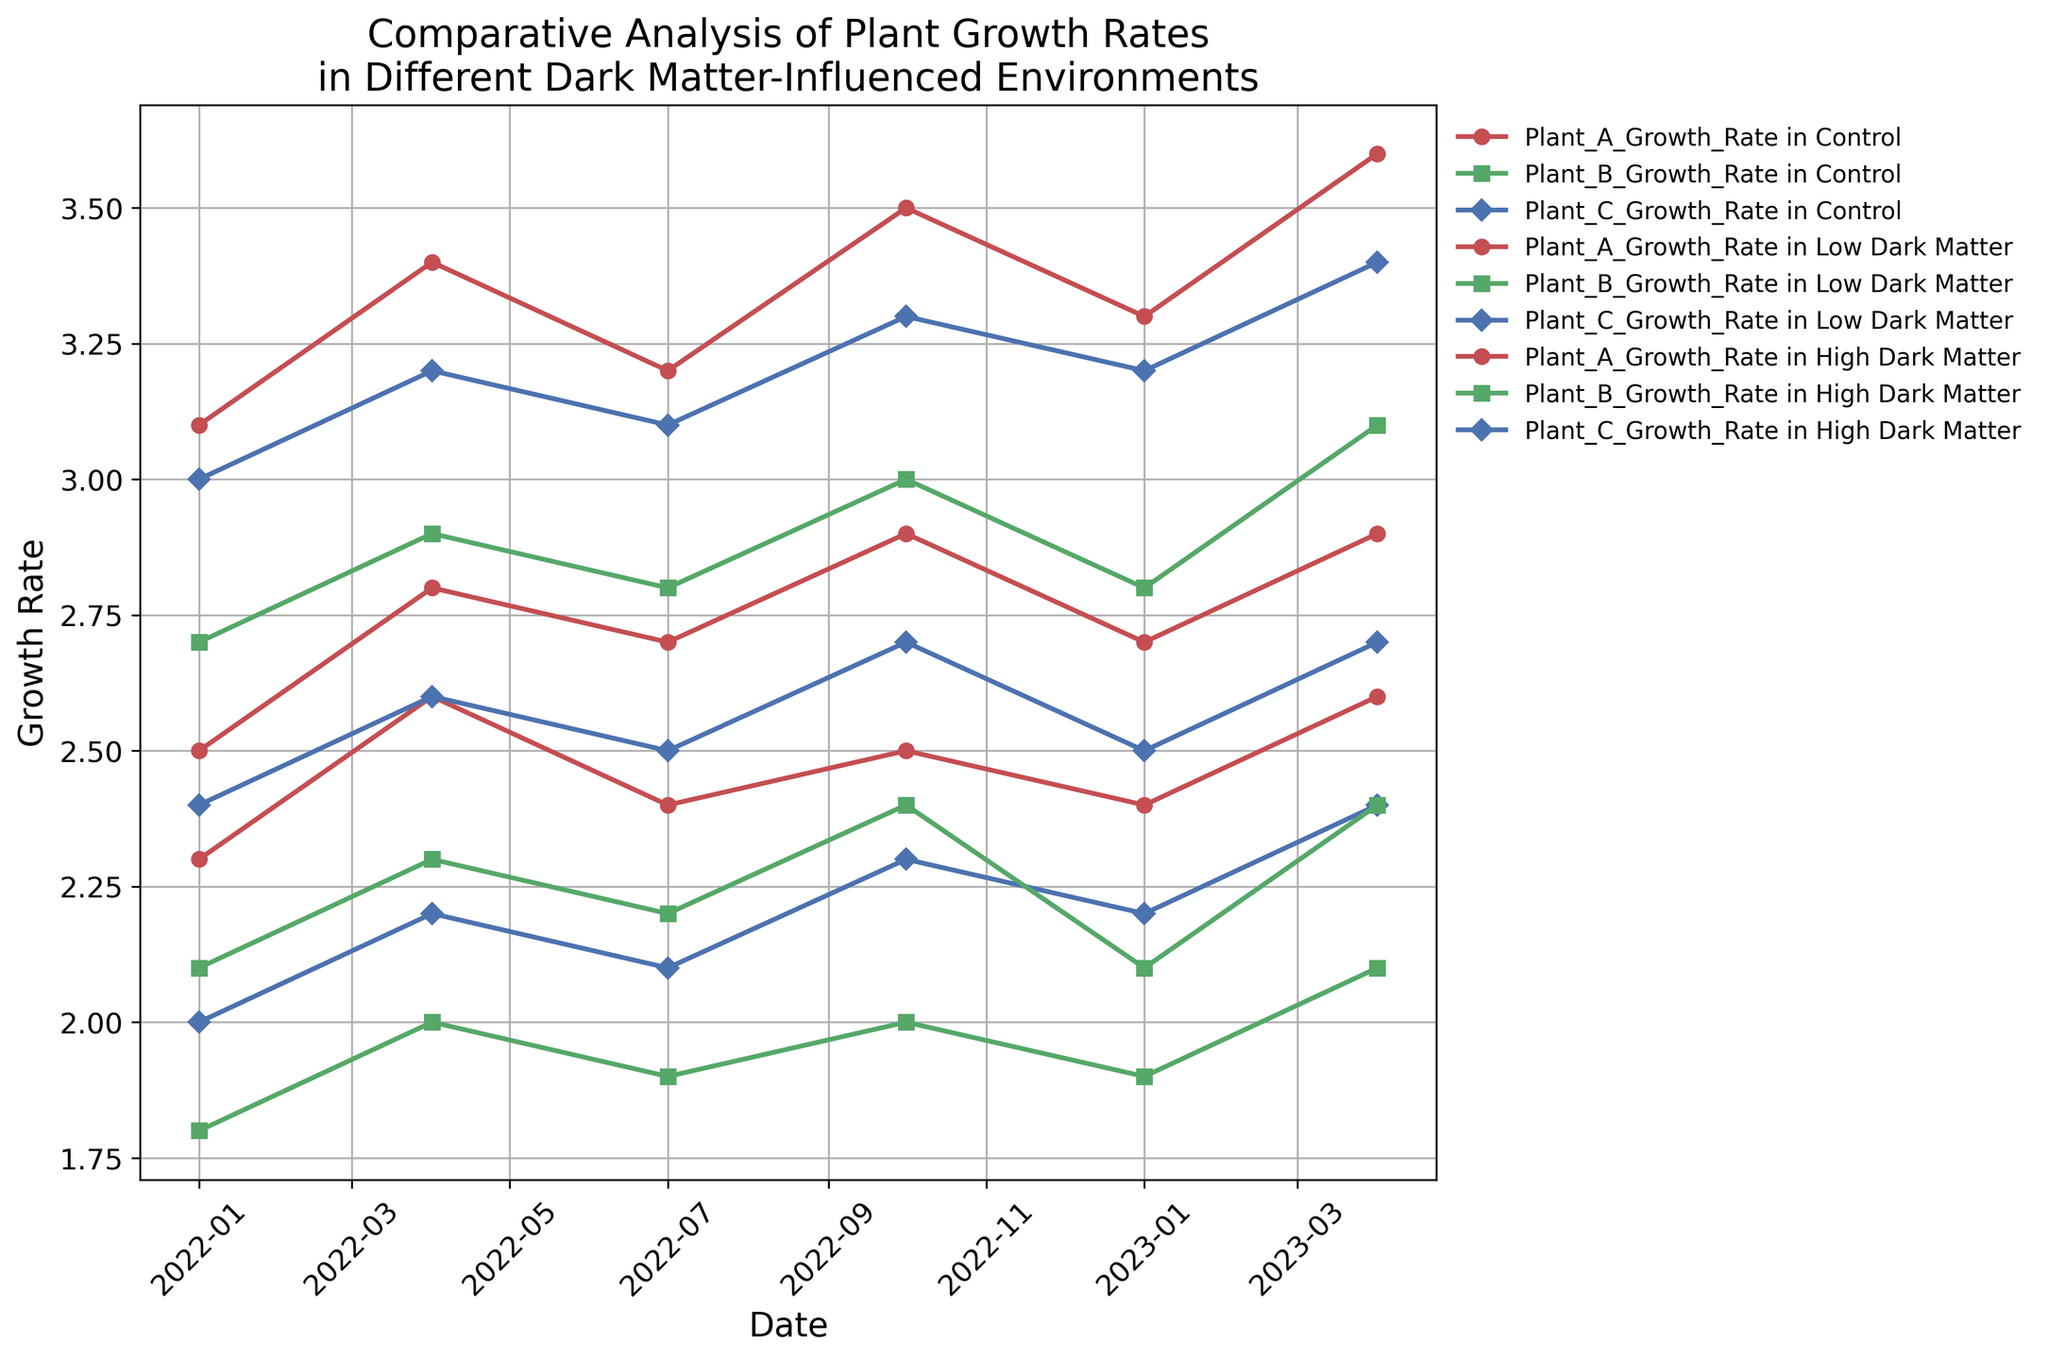What are the plant growth rates for Plant A in the High Dark Matter environment on 2022-04-01 and 2023-04-01? Look at the plot for the High Dark Matter environment and find the growth rate for Plant A on the dates 2022-04-01 and 2023-04-01. On 2022-04-01, it's 3.4, and on 2023-04-01, it's 3.6.
Answer: 3.4 and 3.6 Which environment shows the highest growth rate for Plant C in January 2023? Compare the growth rates of Plant C across all environments in January 2023. The highest growth rate for Plant C in January 2023 is in the High Dark Matter environment with a value of 3.2.
Answer: High Dark Matter Calculate the average growth rate of Plant B in the Low Dark Matter environment over the entire period. Sum the growth rates of Plant B in the Low Dark Matter environment for all given dates and divide by the number of dates. The rates are 2.1, 2.3, 2.2, 2.4, 2.1, 2.4. Sum them up (2.1 + 2.3 + 2.2 + 2.4 + 2.1 + 2.4) = 13.5, and then divide by 6. The average is 13.5/6 = 2.25.
Answer: 2.25 Which Plant shows a consistent increase in growth rate across all environments from January 2022 to April 2023? Check each plant's growth rates across all environments to see if there's a consistent increase from January 2022 to April 2023. Plant A in all environments shows an increase, e.g., High Dark Matter goes from 3.1 to 3.6.
Answer: Plant A Between Control and Low Dark Matter environments, which one shows higher growth rates for Plant B most frequently? Compare the growth rates for Plant B in Control and Low Dark Matter environments across all dates. Control has rates: 1.8, 2.0, 1.9, 2.0, 1.9, 2.1; Low Dark Matter has rates: 2.1, 2.3, 2.2, 2.4, 2.1, 2.4. Low Dark Matter has higher rates on all six dates.
Answer: Low Dark Matter Is there any date where the growth rate of Plant C in Control environment surpasses that of Plant A in the same environment? Compare Plant C and Plant A's growth rates in the Control environment on each date. Plant C never surpasses Plant A's growth rate in the Control environment.
Answer: No What is the total increase in growth rate for Plant A in the High Dark Matter environment from January 2022 to April 2023? Subtract the growth rate of Plant A in High Dark Matter on 2022-01-01 from its growth rate on 2023-04-01. The rates are 3.6 on 2023-04-01 and 3.1 on 2022-01-01. The increase is 3.6 - 3.1 = 0.5.
Answer: 0.5 Which environment shows the least variation in growth rates for Plant C throughout the recorded dates? Calculate the range (difference between maximum and minimum) of growth rates for Plant C in each environment. Control: 2.4 - 2.0 = 0.4, Low Dark Matter: 2.7 - 2.4 = 0.3, High Dark Matter: 3.4 - 3.0 = 0.4. Low Dark Matter has the smallest range with 0.3.
Answer: Low Dark Matter 